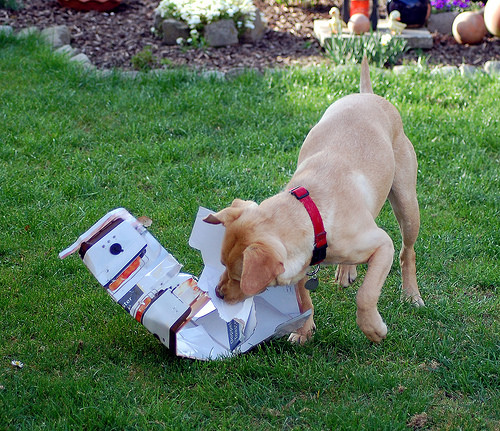<image>
Is the puppy to the left of the grass? Yes. From this viewpoint, the puppy is positioned to the left side relative to the grass. 